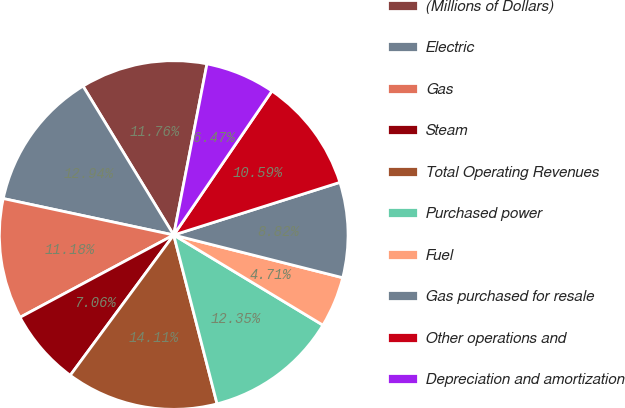<chart> <loc_0><loc_0><loc_500><loc_500><pie_chart><fcel>(Millions of Dollars)<fcel>Electric<fcel>Gas<fcel>Steam<fcel>Total Operating Revenues<fcel>Purchased power<fcel>Fuel<fcel>Gas purchased for resale<fcel>Other operations and<fcel>Depreciation and amortization<nl><fcel>11.76%<fcel>12.94%<fcel>11.18%<fcel>7.06%<fcel>14.11%<fcel>12.35%<fcel>4.71%<fcel>8.82%<fcel>10.59%<fcel>6.47%<nl></chart> 